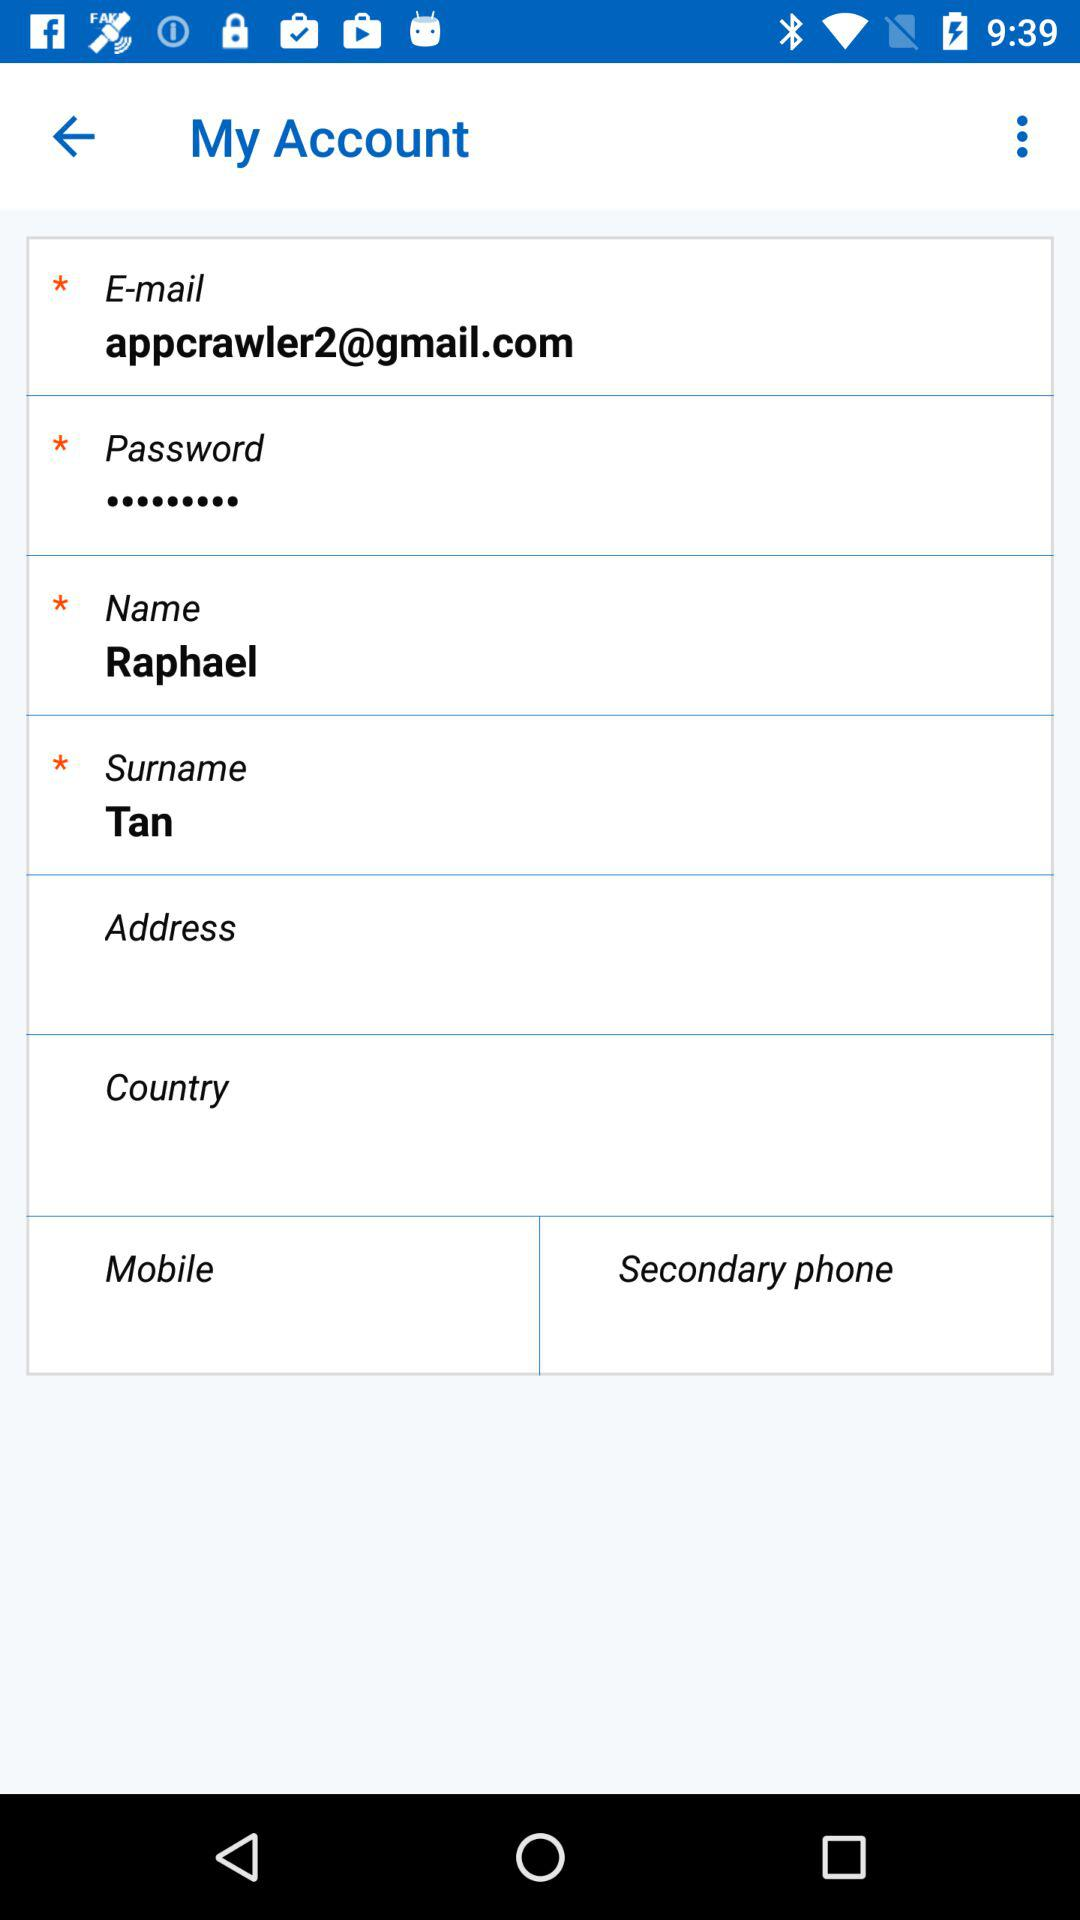What is the surname? The surname is Tan. 